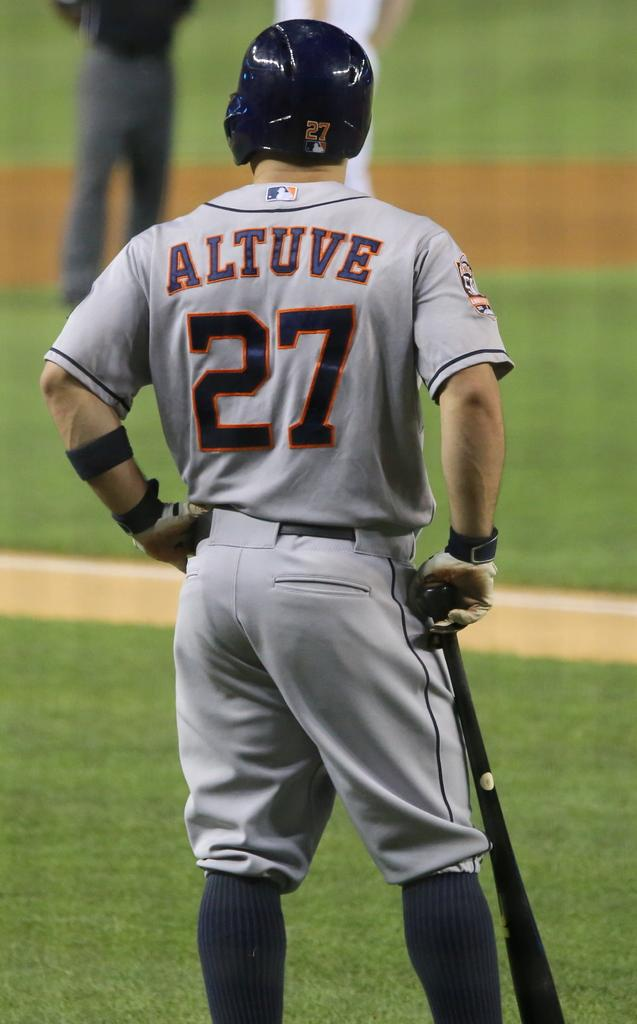<image>
Share a concise interpretation of the image provided. Man wearing jersey number 27 looking onto the field. 